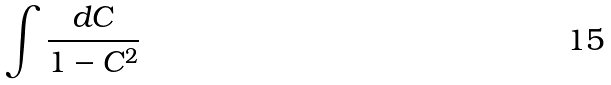<formula> <loc_0><loc_0><loc_500><loc_500>\int \frac { d C } { 1 - C ^ { 2 } }</formula> 